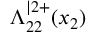<formula> <loc_0><loc_0><loc_500><loc_500>\Lambda _ { 2 2 } ^ { | 2 + } ( x _ { 2 } )</formula> 